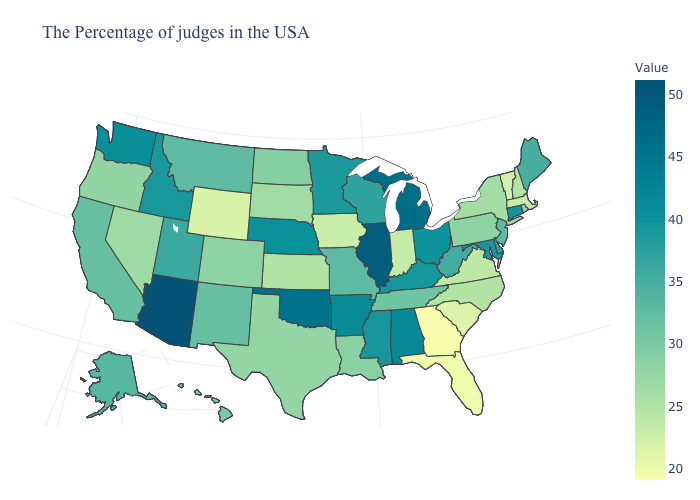Among the states that border Utah , which have the highest value?
Concise answer only. Arizona. Is the legend a continuous bar?
Keep it brief. Yes. Does Iowa have the lowest value in the MidWest?
Be succinct. Yes. Does Wyoming have the highest value in the USA?
Quick response, please. No. Among the states that border Kentucky , which have the lowest value?
Quick response, please. Indiana. Which states have the lowest value in the USA?
Quick response, please. Georgia. 